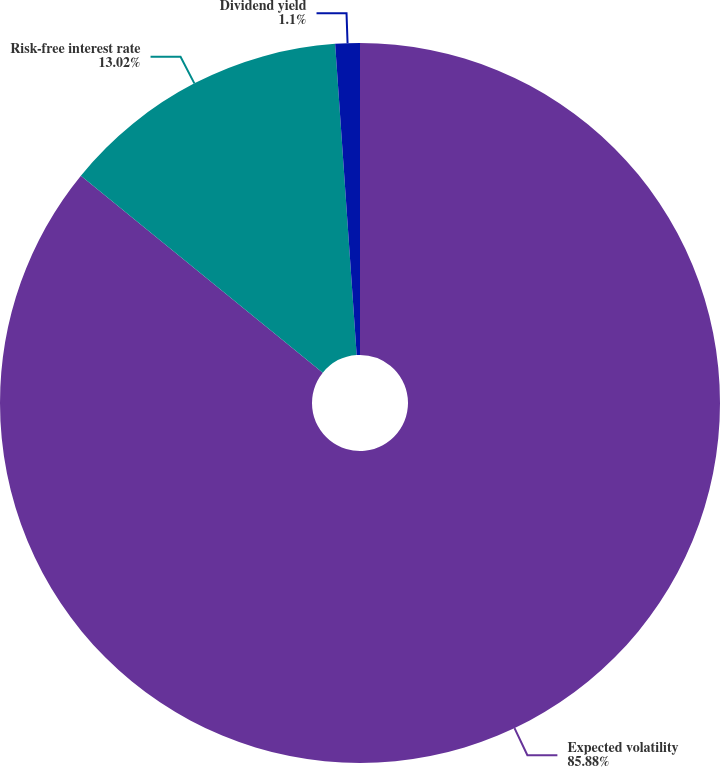<chart> <loc_0><loc_0><loc_500><loc_500><pie_chart><fcel>Expected volatility<fcel>Risk-free interest rate<fcel>Dividend yield<nl><fcel>85.88%<fcel>13.02%<fcel>1.1%<nl></chart> 